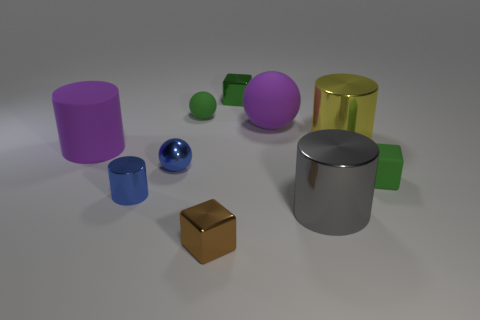What time of day or lighting setting do you think is represented in this image? The lighting in the image does not depict a natural environment but rather suggests an artificial and neutral light setup, commonly used in studio photography, which provides soft shadows and an overall even illumination of the objects. 